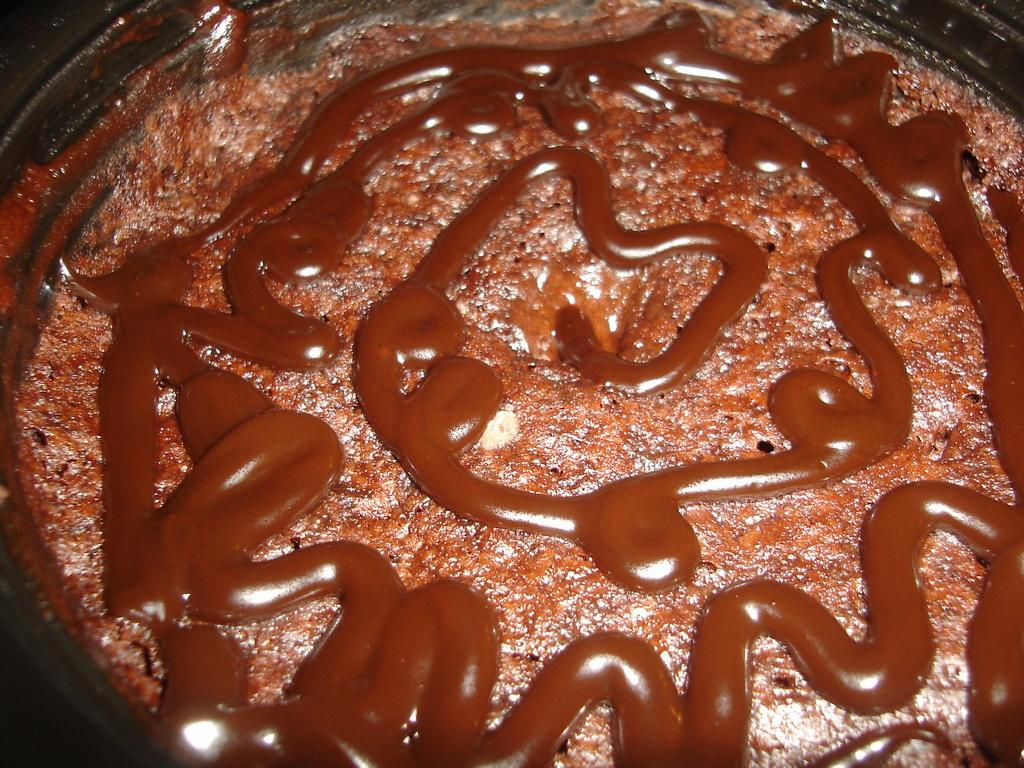What is the main subject of the image? There is a food item on a plate in the image. What type of sweater is the achiever wearing in the image? There is no achiever or sweater present in the image; it only features a food item on a plate. 